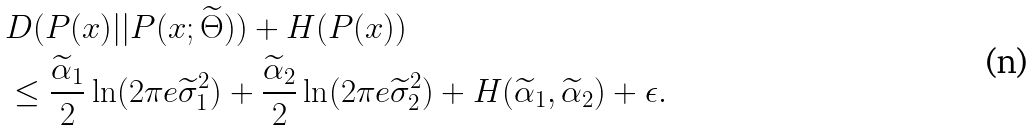<formula> <loc_0><loc_0><loc_500><loc_500>& D ( P ( x ) | | P ( x ; \widetilde { \Theta } ) ) + H ( P ( x ) ) \\ & \leq \frac { \widetilde { \alpha } _ { 1 } } { 2 } \ln ( 2 \pi e \widetilde { \sigma } _ { 1 } ^ { 2 } ) + \frac { \widetilde { \alpha } _ { 2 } } { 2 } \ln ( 2 \pi e \widetilde { \sigma } _ { 2 } ^ { 2 } ) + H ( \widetilde { \alpha } _ { 1 } , \widetilde { \alpha } _ { 2 } ) + \epsilon .</formula> 